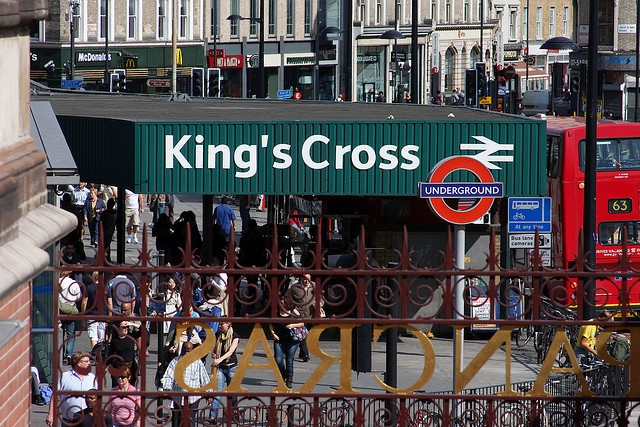Describe the objects in this image and their specific colors. I can see people in gray, black, maroon, and lightgray tones, bus in gray, brown, black, and maroon tones, people in gray, black, maroon, and olive tones, people in gray, black, navy, and blue tones, and people in gray, black, maroon, and white tones in this image. 